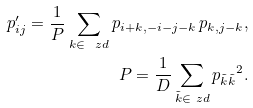Convert formula to latex. <formula><loc_0><loc_0><loc_500><loc_500>p _ { i j } ^ { \prime } = \frac { 1 } { P } \sum _ { k \in \ z d } p _ { i + k , - i - j - k } \, p _ { k , j - k } , \\ P = \frac { 1 } { D } \sum _ { \tilde { k } \in \ z d } { p _ { \tilde { k } \tilde { k } } } ^ { 2 } .</formula> 